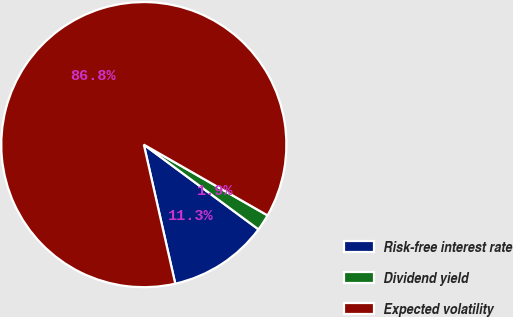<chart> <loc_0><loc_0><loc_500><loc_500><pie_chart><fcel>Risk-free interest rate<fcel>Dividend yield<fcel>Expected volatility<nl><fcel>11.33%<fcel>1.86%<fcel>86.81%<nl></chart> 